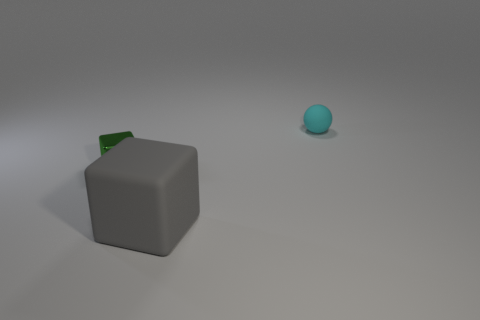Add 2 gray shiny cylinders. How many objects exist? 5 Subtract all balls. How many objects are left? 2 Add 2 metallic things. How many metallic things are left? 3 Add 3 green objects. How many green objects exist? 4 Subtract 0 cyan blocks. How many objects are left? 3 Subtract all gray matte objects. Subtract all shiny objects. How many objects are left? 1 